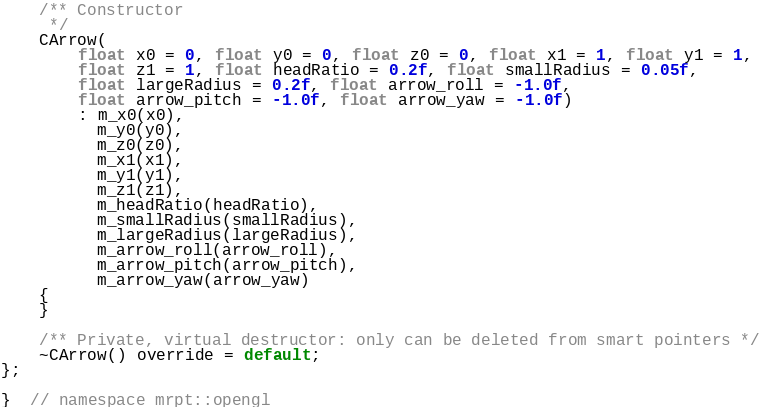<code> <loc_0><loc_0><loc_500><loc_500><_C_>	/** Constructor
	 */
	CArrow(
		float x0 = 0, float y0 = 0, float z0 = 0, float x1 = 1, float y1 = 1,
		float z1 = 1, float headRatio = 0.2f, float smallRadius = 0.05f,
		float largeRadius = 0.2f, float arrow_roll = -1.0f,
		float arrow_pitch = -1.0f, float arrow_yaw = -1.0f)
		: m_x0(x0),
		  m_y0(y0),
		  m_z0(z0),
		  m_x1(x1),
		  m_y1(y1),
		  m_z1(z1),
		  m_headRatio(headRatio),
		  m_smallRadius(smallRadius),
		  m_largeRadius(largeRadius),
		  m_arrow_roll(arrow_roll),
		  m_arrow_pitch(arrow_pitch),
		  m_arrow_yaw(arrow_yaw)
	{
	}

	/** Private, virtual destructor: only can be deleted from smart pointers */
	~CArrow() override = default;
};

}  // namespace mrpt::opengl
</code> 